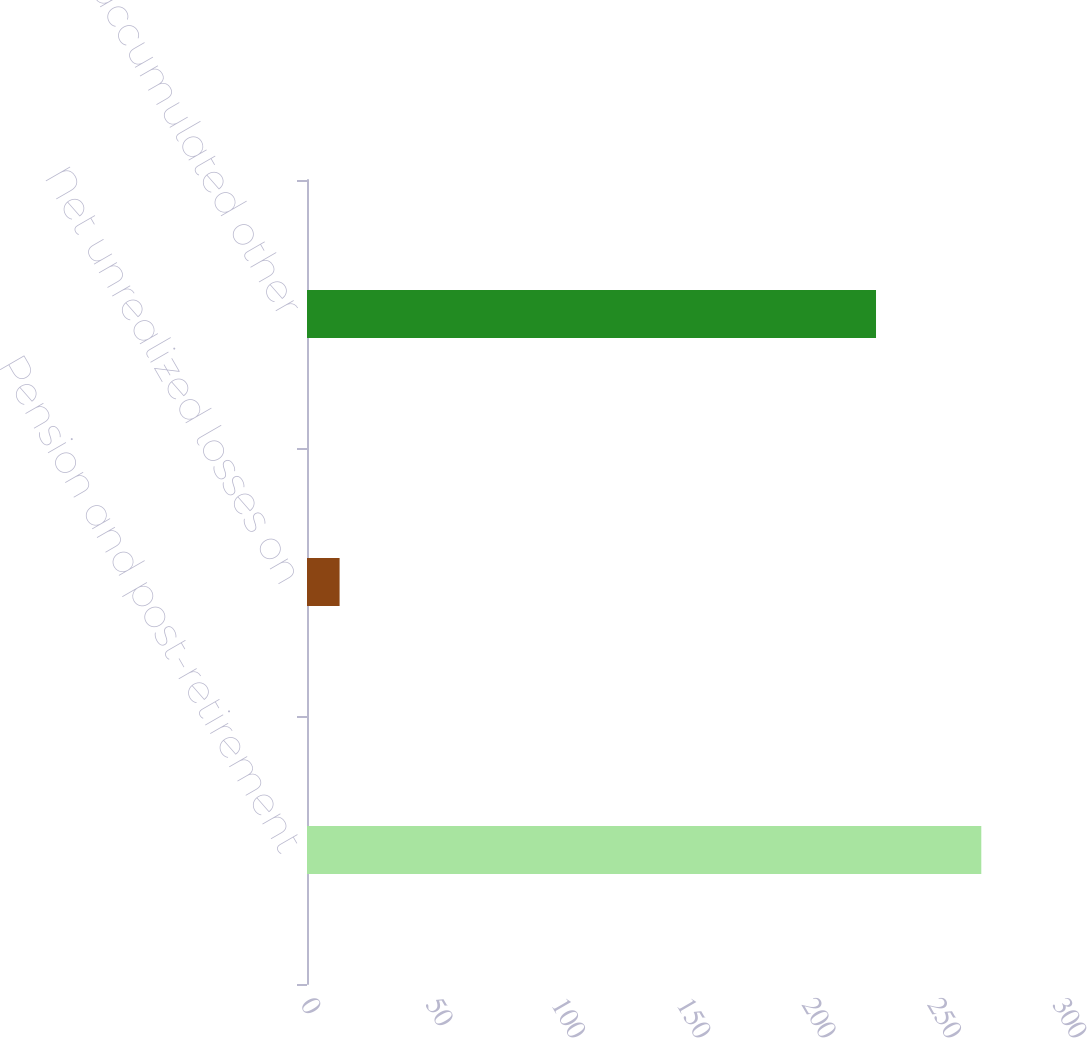Convert chart. <chart><loc_0><loc_0><loc_500><loc_500><bar_chart><fcel>Pension and post-retirement<fcel>Net unrealized losses on<fcel>Total accumulated other<nl><fcel>269<fcel>13<fcel>227<nl></chart> 